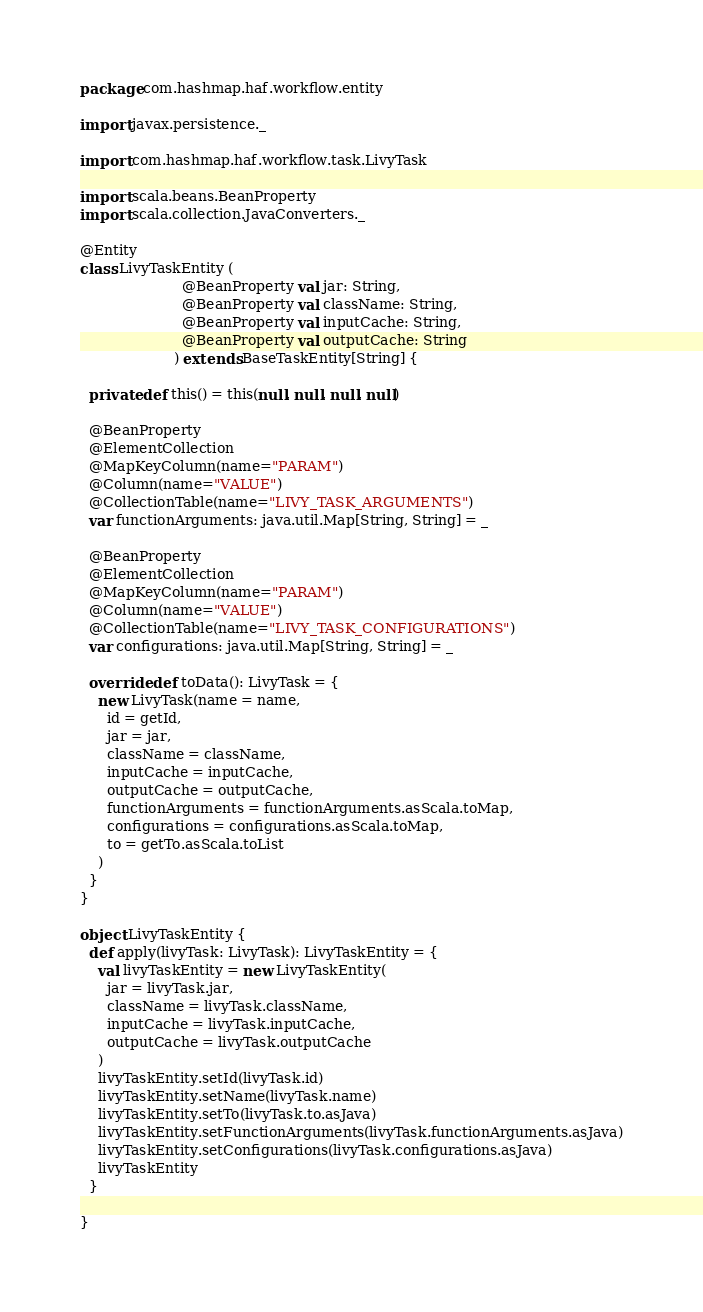<code> <loc_0><loc_0><loc_500><loc_500><_Scala_>package com.hashmap.haf.workflow.entity

import javax.persistence._

import com.hashmap.haf.workflow.task.LivyTask

import scala.beans.BeanProperty
import scala.collection.JavaConverters._

@Entity
class LivyTaskEntity (
                       @BeanProperty val jar: String,
                       @BeanProperty val className: String,
                       @BeanProperty val inputCache: String,
                       @BeanProperty val outputCache: String
                     ) extends BaseTaskEntity[String] {

  private def this() = this(null, null, null, null)

  @BeanProperty
  @ElementCollection
  @MapKeyColumn(name="PARAM")
  @Column(name="VALUE")
  @CollectionTable(name="LIVY_TASK_ARGUMENTS")
  var functionArguments: java.util.Map[String, String] = _

  @BeanProperty
  @ElementCollection
  @MapKeyColumn(name="PARAM")
  @Column(name="VALUE")
  @CollectionTable(name="LIVY_TASK_CONFIGURATIONS")
  var configurations: java.util.Map[String, String] = _

  override def toData(): LivyTask = {
    new LivyTask(name = name,
      id = getId,
      jar = jar,
      className = className,
      inputCache = inputCache,
      outputCache = outputCache,
      functionArguments = functionArguments.asScala.toMap,
      configurations = configurations.asScala.toMap,
      to = getTo.asScala.toList
    )
  }
}

object LivyTaskEntity {
  def apply(livyTask: LivyTask): LivyTaskEntity = {
    val livyTaskEntity = new LivyTaskEntity(
      jar = livyTask.jar,
      className = livyTask.className,
      inputCache = livyTask.inputCache,
      outputCache = livyTask.outputCache
    )
    livyTaskEntity.setId(livyTask.id)
    livyTaskEntity.setName(livyTask.name)
    livyTaskEntity.setTo(livyTask.to.asJava)
    livyTaskEntity.setFunctionArguments(livyTask.functionArguments.asJava)
    livyTaskEntity.setConfigurations(livyTask.configurations.asJava)
    livyTaskEntity
  }

}
</code> 